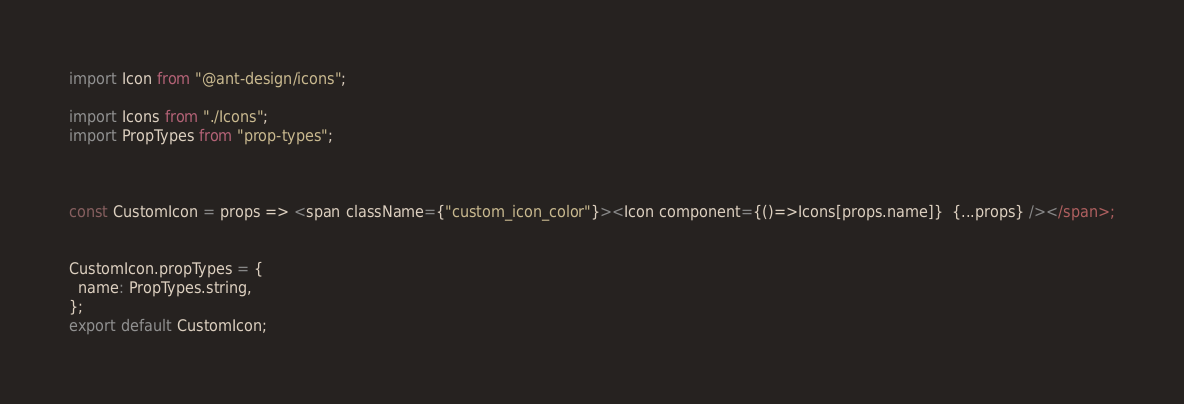Convert code to text. <code><loc_0><loc_0><loc_500><loc_500><_JavaScript_>import Icon from "@ant-design/icons";

import Icons from "./Icons";
import PropTypes from "prop-types";



const CustomIcon = props => <span className={"custom_icon_color"}><Icon component={()=>Icons[props.name]}  {...props} /></span>;


CustomIcon.propTypes = {
  name: PropTypes.string,
};
export default CustomIcon;
</code> 